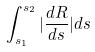Convert formula to latex. <formula><loc_0><loc_0><loc_500><loc_500>\int _ { s _ { 1 } } ^ { s _ { 2 } } | \frac { d R } { d s } | d s</formula> 